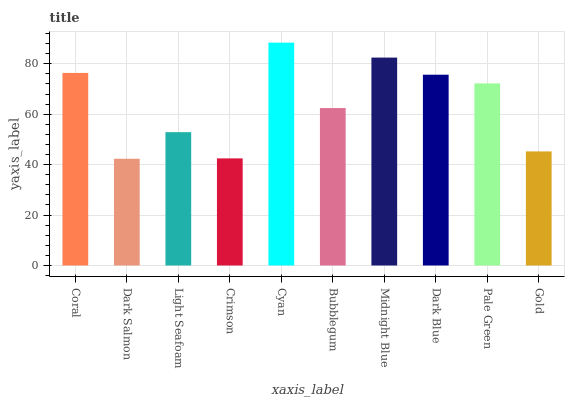Is Dark Salmon the minimum?
Answer yes or no. Yes. Is Cyan the maximum?
Answer yes or no. Yes. Is Light Seafoam the minimum?
Answer yes or no. No. Is Light Seafoam the maximum?
Answer yes or no. No. Is Light Seafoam greater than Dark Salmon?
Answer yes or no. Yes. Is Dark Salmon less than Light Seafoam?
Answer yes or no. Yes. Is Dark Salmon greater than Light Seafoam?
Answer yes or no. No. Is Light Seafoam less than Dark Salmon?
Answer yes or no. No. Is Pale Green the high median?
Answer yes or no. Yes. Is Bubblegum the low median?
Answer yes or no. Yes. Is Crimson the high median?
Answer yes or no. No. Is Cyan the low median?
Answer yes or no. No. 